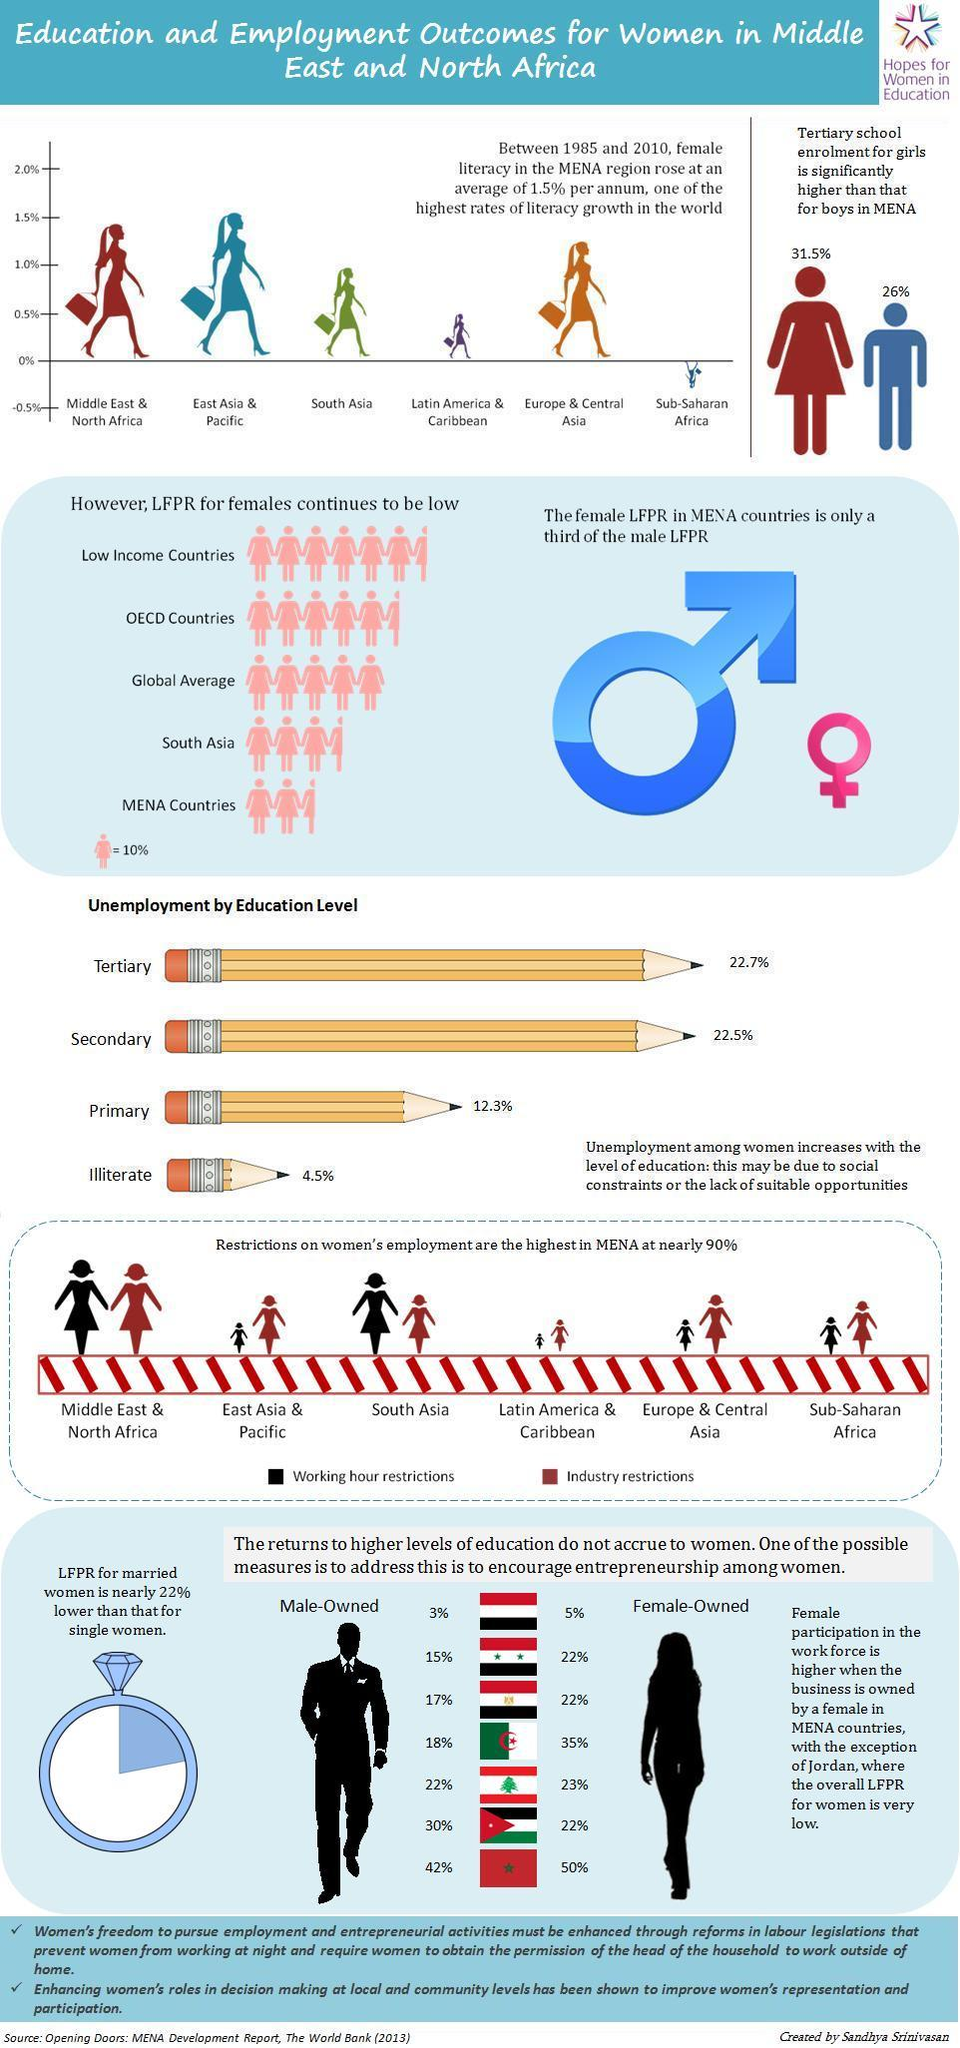Mention a couple of crucial points in this snapshot. The global average LFPR for females is 50%, with regional variations. The Middle East and North Africa region had the second highest female literacy growth rate in the graph. The tertiary school enrollment percentage for boys in the Middle East and North Africa (MENA) region is 26%. According to the Latin America & Caribbean region, the working hour restrictions for women are the least. According to the graph, Sub-Saharan Africa is the region that exhibits a declining trend in female literacy growth. 